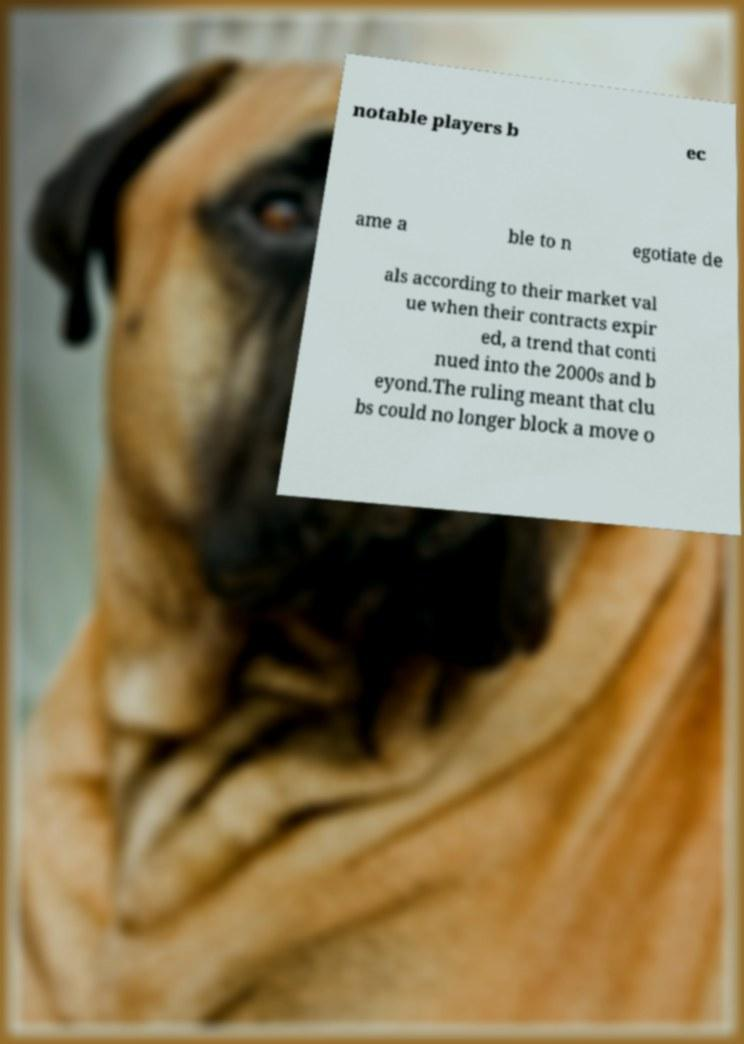Could you extract and type out the text from this image? notable players b ec ame a ble to n egotiate de als according to their market val ue when their contracts expir ed, a trend that conti nued into the 2000s and b eyond.The ruling meant that clu bs could no longer block a move o 